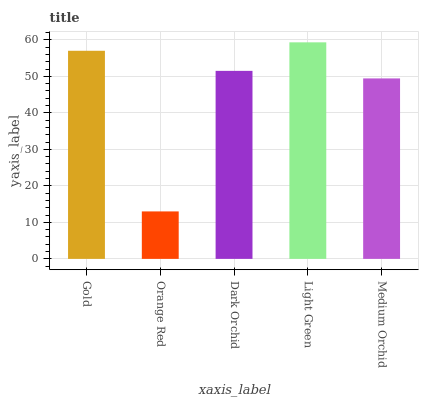Is Orange Red the minimum?
Answer yes or no. Yes. Is Light Green the maximum?
Answer yes or no. Yes. Is Dark Orchid the minimum?
Answer yes or no. No. Is Dark Orchid the maximum?
Answer yes or no. No. Is Dark Orchid greater than Orange Red?
Answer yes or no. Yes. Is Orange Red less than Dark Orchid?
Answer yes or no. Yes. Is Orange Red greater than Dark Orchid?
Answer yes or no. No. Is Dark Orchid less than Orange Red?
Answer yes or no. No. Is Dark Orchid the high median?
Answer yes or no. Yes. Is Dark Orchid the low median?
Answer yes or no. Yes. Is Light Green the high median?
Answer yes or no. No. Is Light Green the low median?
Answer yes or no. No. 